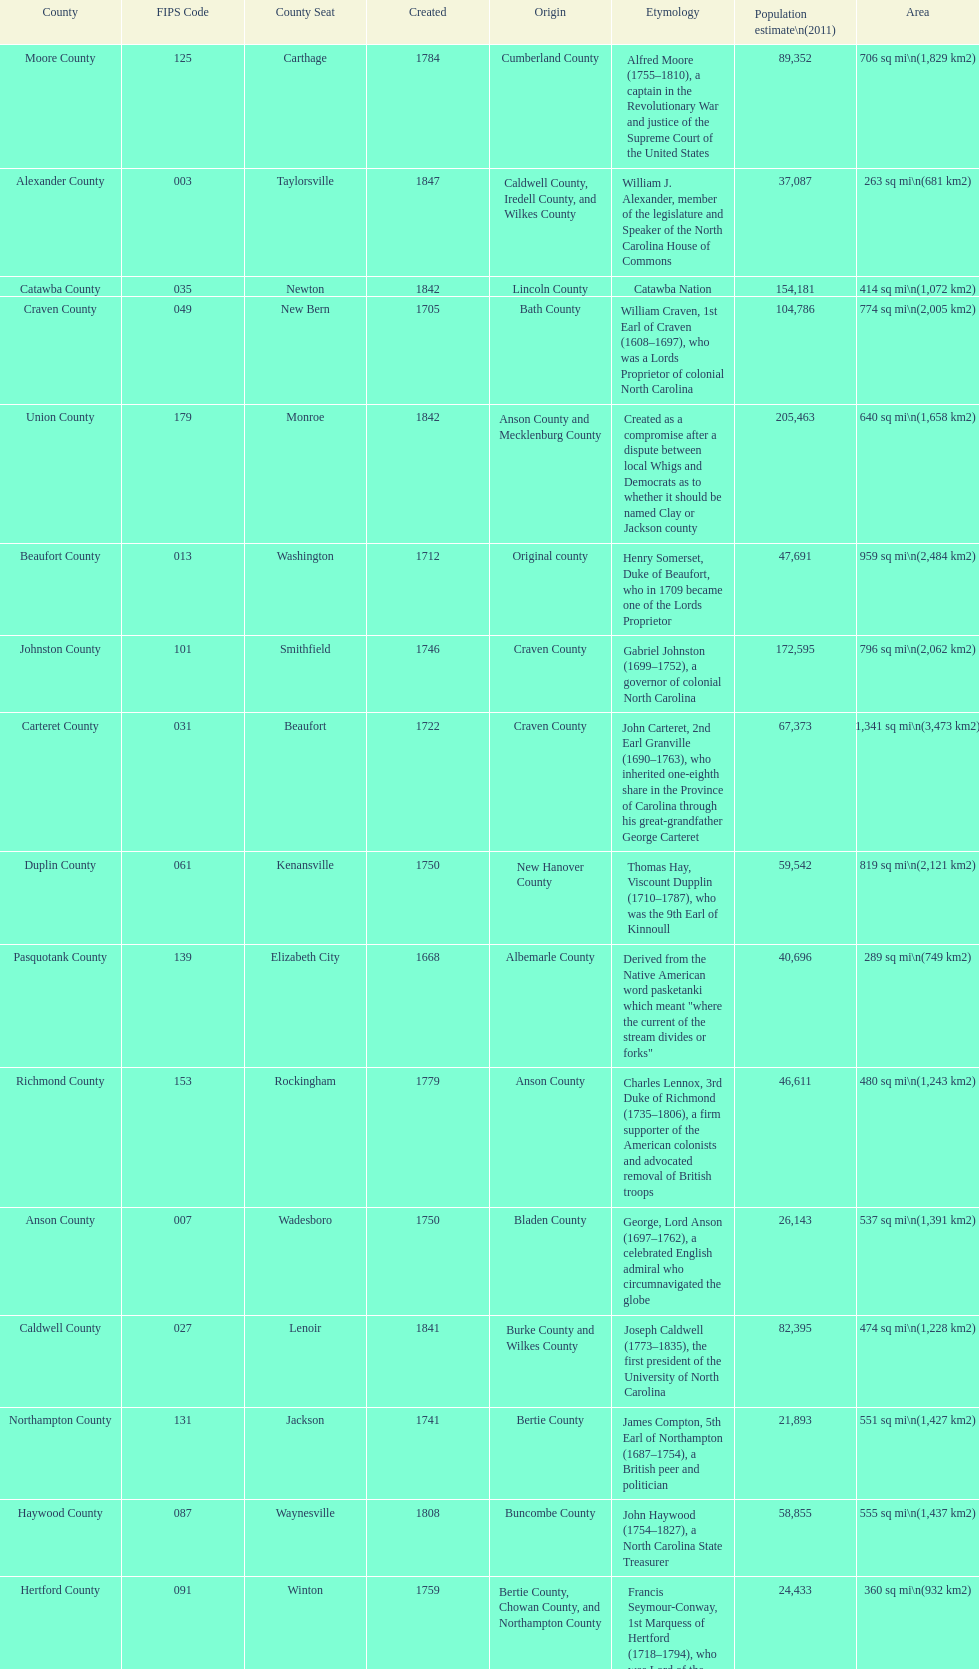What is the number of counties created in the 1800s? 37. 